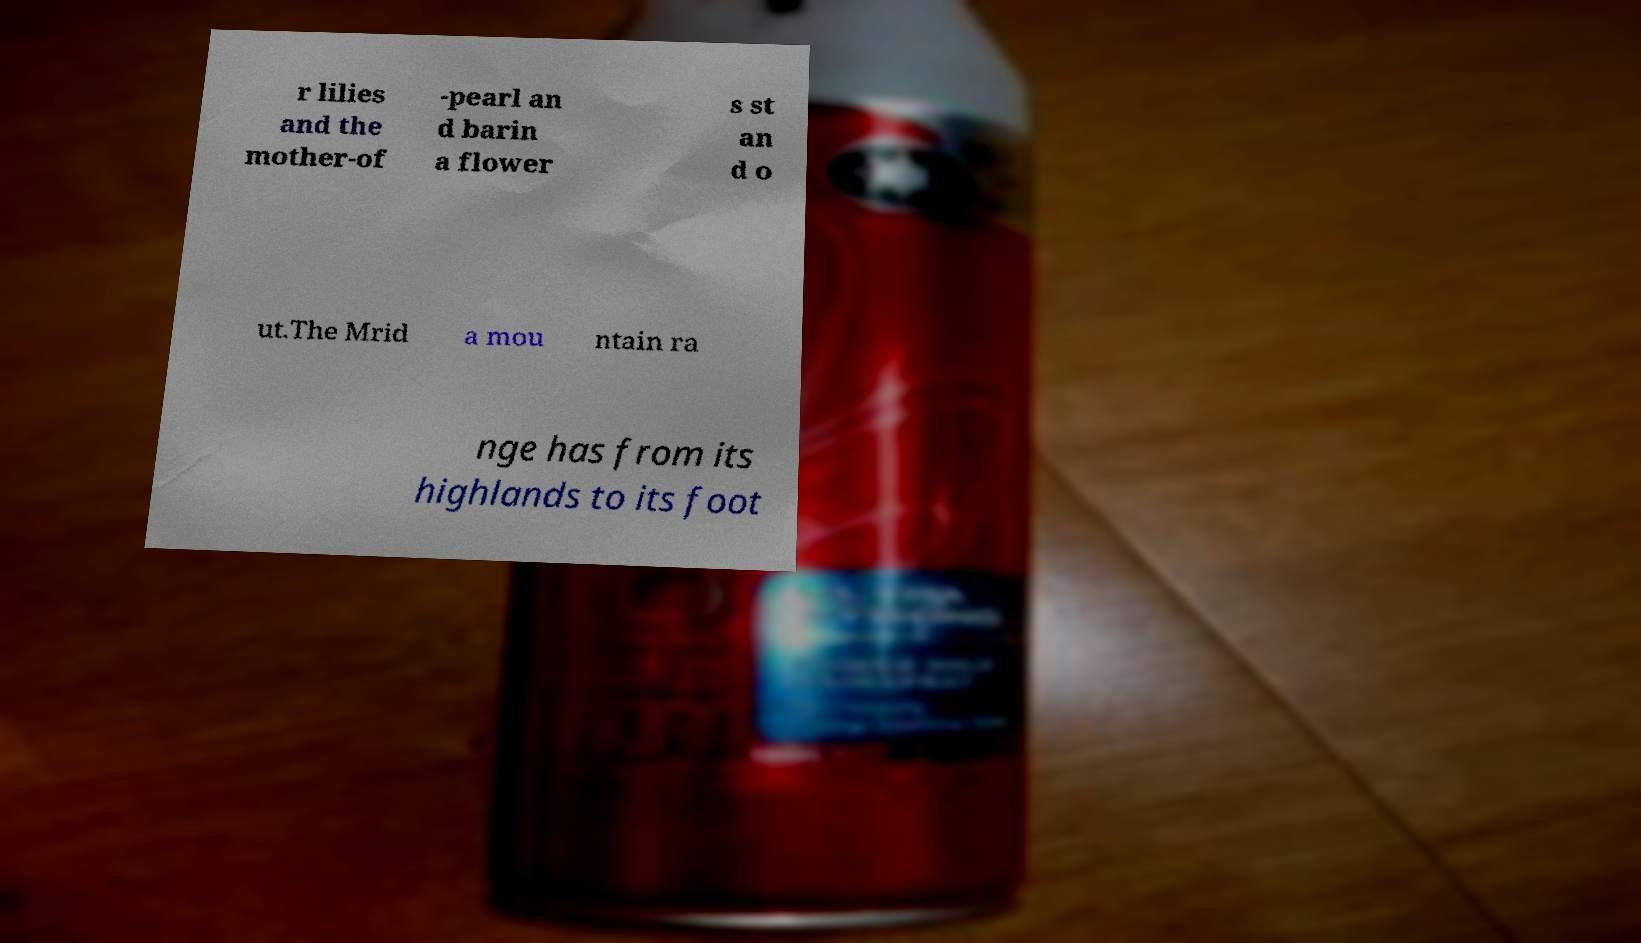There's text embedded in this image that I need extracted. Can you transcribe it verbatim? r lilies and the mother-of -pearl an d barin a flower s st an d o ut.The Mrid a mou ntain ra nge has from its highlands to its foot 